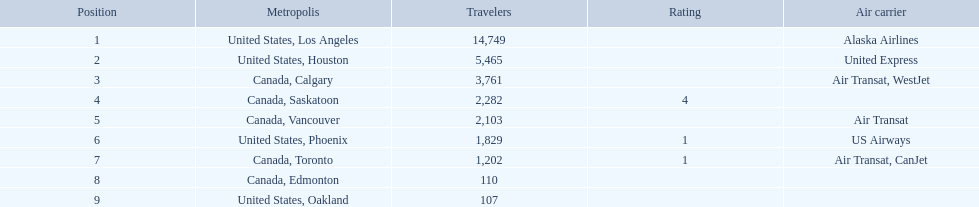What are all the cities? United States, Los Angeles, United States, Houston, Canada, Calgary, Canada, Saskatoon, Canada, Vancouver, United States, Phoenix, Canada, Toronto, Canada, Edmonton, United States, Oakland. How many passengers do they service? 14,749, 5,465, 3,761, 2,282, 2,103, 1,829, 1,202, 110, 107. Which city, when combined with los angeles, totals nearly 19,000? Canada, Calgary. 